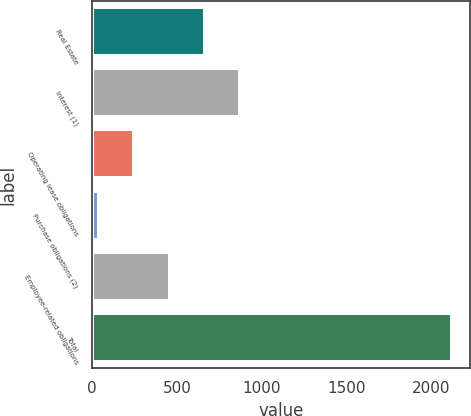Convert chart. <chart><loc_0><loc_0><loc_500><loc_500><bar_chart><fcel>Real Estate<fcel>Interest (1)<fcel>Operating lease obligations<fcel>Purchase obligations (2)<fcel>Employee-related obligations<fcel>Total<nl><fcel>666.5<fcel>875<fcel>249.5<fcel>41<fcel>458<fcel>2126<nl></chart> 